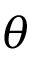Convert formula to latex. <formula><loc_0><loc_0><loc_500><loc_500>\theta</formula> 